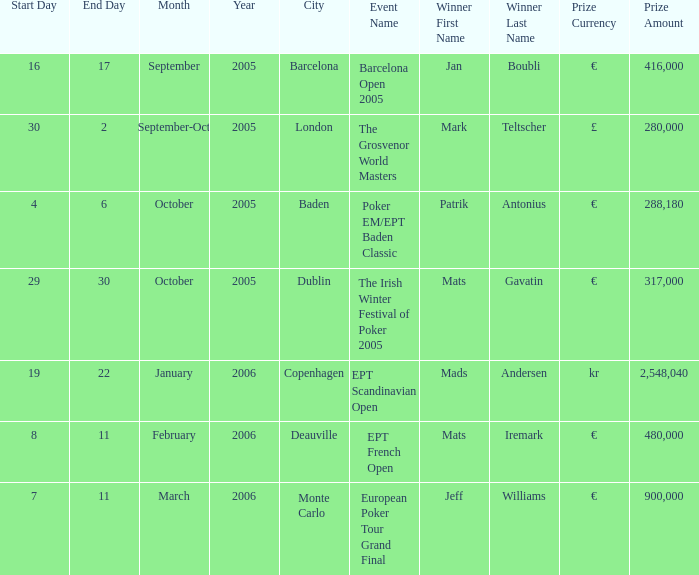What competition did mark teltscher emerge victorious in? The Grosvenor World Masters. Give me the full table as a dictionary. {'header': ['Start Day', 'End Day', 'Month', 'Year', 'City', 'Event Name', 'Winner First Name', 'Winner Last Name', 'Prize Currency', 'Prize Amount'], 'rows': [['16', '17', 'September', '2005', 'Barcelona', 'Barcelona Open 2005', 'Jan', 'Boubli', '€', '416,000'], ['30', '2', 'September-Oct', '2005', 'London', 'The Grosvenor World Masters', 'Mark', 'Teltscher', '£', '280,000'], ['4', '6', 'October', '2005', 'Baden', 'Poker EM/EPT Baden Classic', 'Patrik', 'Antonius', '€', '288,180'], ['29', '30', 'October', '2005', 'Dublin', 'The Irish Winter Festival of Poker 2005', 'Mats', 'Gavatin', '€', '317,000'], ['19', '22', 'January', '2006', 'Copenhagen', 'EPT Scandinavian Open', 'Mads', 'Andersen', 'kr', '2,548,040'], ['8', '11', 'February', '2006', 'Deauville', 'EPT French Open', 'Mats', 'Iremark', '€', '480,000'], ['7', '11', 'March', '2006', 'Monte Carlo', 'European Poker Tour Grand Final', 'Jeff', 'Williams', '€', '900,000']]} 